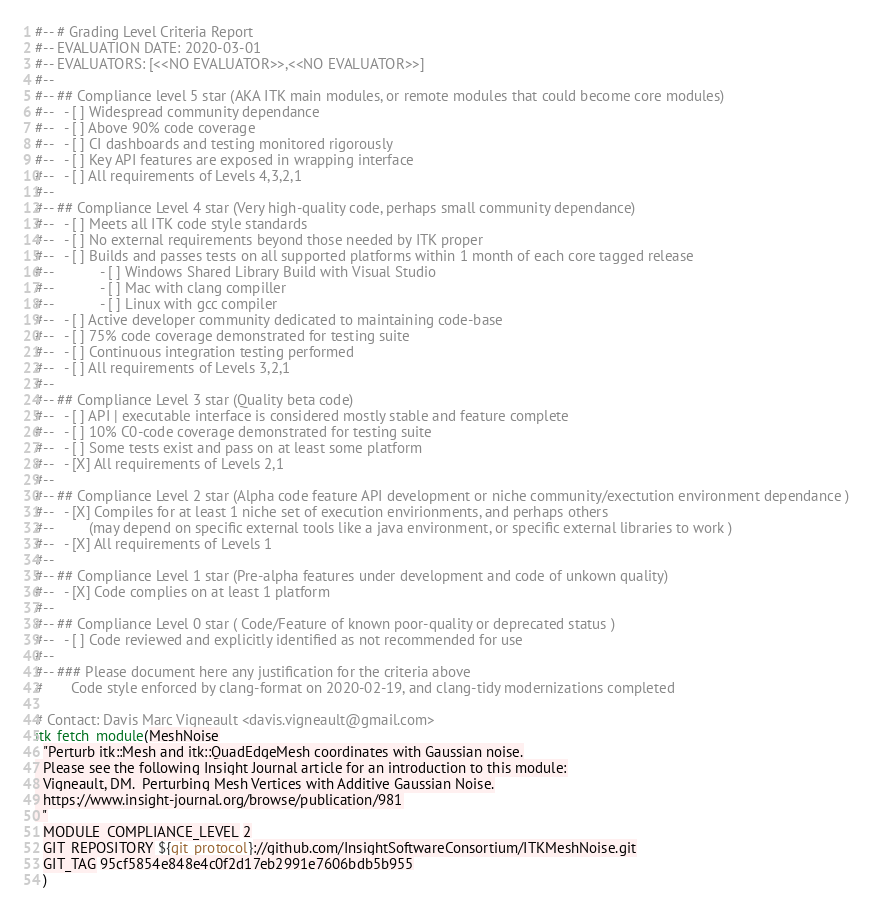<code> <loc_0><loc_0><loc_500><loc_500><_CMake_>#-- # Grading Level Criteria Report
#-- EVALUATION DATE: 2020-03-01
#-- EVALUATORS: [<<NO EVALUATOR>>,<<NO EVALUATOR>>]
#--
#-- ## Compliance level 5 star (AKA ITK main modules, or remote modules that could become core modules)
#--   - [ ] Widespread community dependance
#--   - [ ] Above 90% code coverage
#--   - [ ] CI dashboards and testing monitored rigorously
#--   - [ ] Key API features are exposed in wrapping interface
#--   - [ ] All requirements of Levels 4,3,2,1
#--
#-- ## Compliance Level 4 star (Very high-quality code, perhaps small community dependance)
#--   - [ ] Meets all ITK code style standards
#--   - [ ] No external requirements beyond those needed by ITK proper
#--   - [ ] Builds and passes tests on all supported platforms within 1 month of each core tagged release
#--            - [ ] Windows Shared Library Build with Visual Studio
#--            - [ ] Mac with clang compiller
#--            - [ ] Linux with gcc compiler
#--   - [ ] Active developer community dedicated to maintaining code-base
#--   - [ ] 75% code coverage demonstrated for testing suite
#--   - [ ] Continuous integration testing performed
#--   - [ ] All requirements of Levels 3,2,1
#--
#-- ## Compliance Level 3 star (Quality beta code)
#--   - [ ] API | executable interface is considered mostly stable and feature complete
#--   - [ ] 10% C0-code coverage demonstrated for testing suite
#--   - [ ] Some tests exist and pass on at least some platform
#--   - [X] All requirements of Levels 2,1
#--
#-- ## Compliance Level 2 star (Alpha code feature API development or niche community/exectution environment dependance )
#--   - [X] Compiles for at least 1 niche set of execution envirionments, and perhaps others
#--         (may depend on specific external tools like a java environment, or specific external libraries to work )
#--   - [X] All requirements of Levels 1
#--
#-- ## Compliance Level 1 star (Pre-alpha features under development and code of unkown quality)
#--   - [X] Code complies on at least 1 platform
#--
#-- ## Compliance Level 0 star ( Code/Feature of known poor-quality or deprecated status )
#--   - [ ] Code reviewed and explicitly identified as not recommended for use
#--
#-- ### Please document here any justification for the criteria above
#       Code style enforced by clang-format on 2020-02-19, and clang-tidy modernizations completed

# Contact: Davis Marc Vigneault <davis.vigneault@gmail.com>
itk_fetch_module(MeshNoise
  "Perturb itk::Mesh and itk::QuadEdgeMesh coordinates with Gaussian noise.
  Please see the following Insight Journal article for an introduction to this module:
  Vigneault, DM.  Perturbing Mesh Vertices with Additive Gaussian Noise.
  https://www.insight-journal.org/browse/publication/981
  "
  MODULE_COMPLIANCE_LEVEL 2
  GIT_REPOSITORY ${git_protocol}://github.com/InsightSoftwareConsortium/ITKMeshNoise.git
  GIT_TAG 95cf5854e848e4c0f2d17eb2991e7606bdb5b955
  )
</code> 